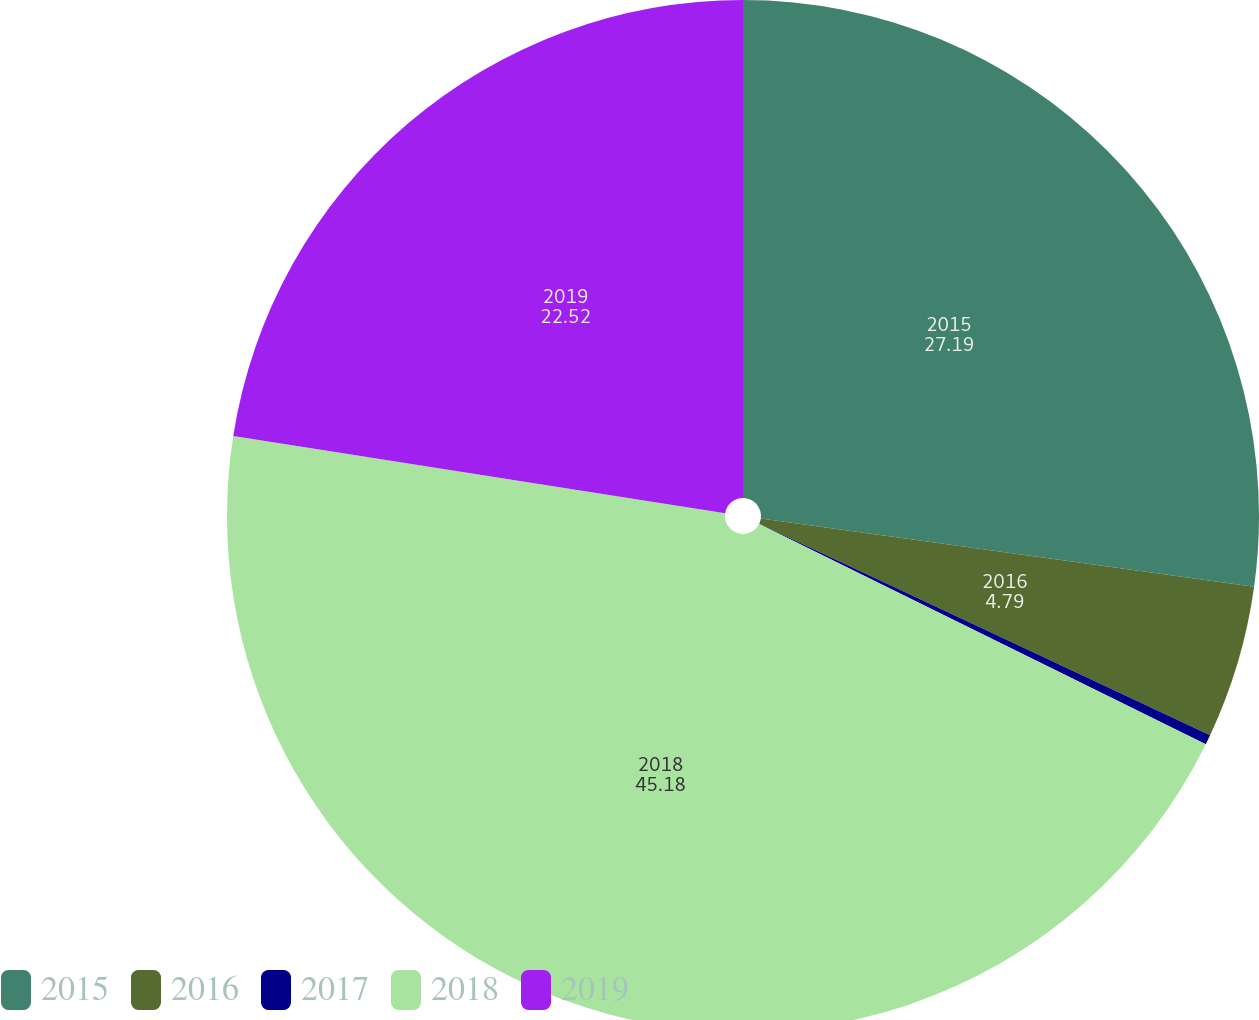Convert chart. <chart><loc_0><loc_0><loc_500><loc_500><pie_chart><fcel>2015<fcel>2016<fcel>2017<fcel>2018<fcel>2019<nl><fcel>27.19%<fcel>4.79%<fcel>0.31%<fcel>45.18%<fcel>22.52%<nl></chart> 